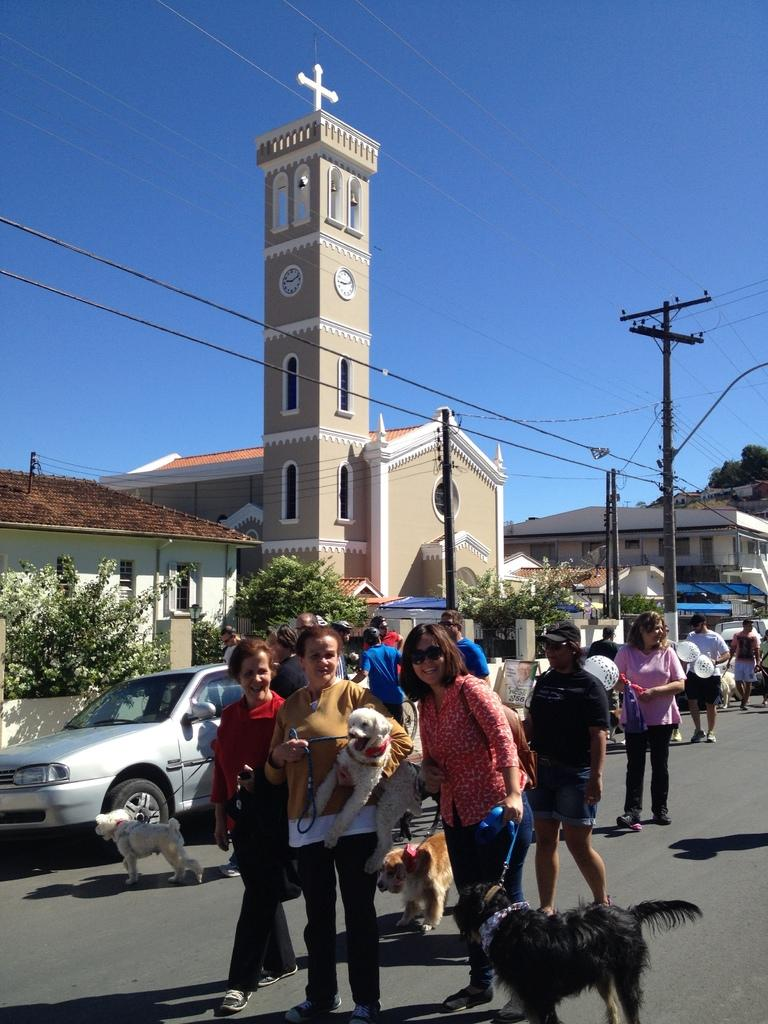What type of structure can be seen in the image? There is a building in the image. What part of the natural environment is visible in the image? The sky is visible in the image. What type of utility pole is present in the image? There is a current pole in the image. What type of residential structures are present in the image? There are houses in the image. What type of vegetation is present in the image? Trees are present in the image. What type of activity is happening on the road in the image? There are people standing on the road and dogs are visible on the road in the image. What type of vehicle is present on the road in the image? There is a car on the road in the image. What type of profit can be seen in the image? There is no mention of profit in the image, as it features a building, sky, current pole, houses, trees, people, dogs, and a car on the road. What type of boundary is visible in the image? There is no mention of a boundary in the image, as it features a building, sky, current pole, houses, trees, people, dogs, and a car on the road. 